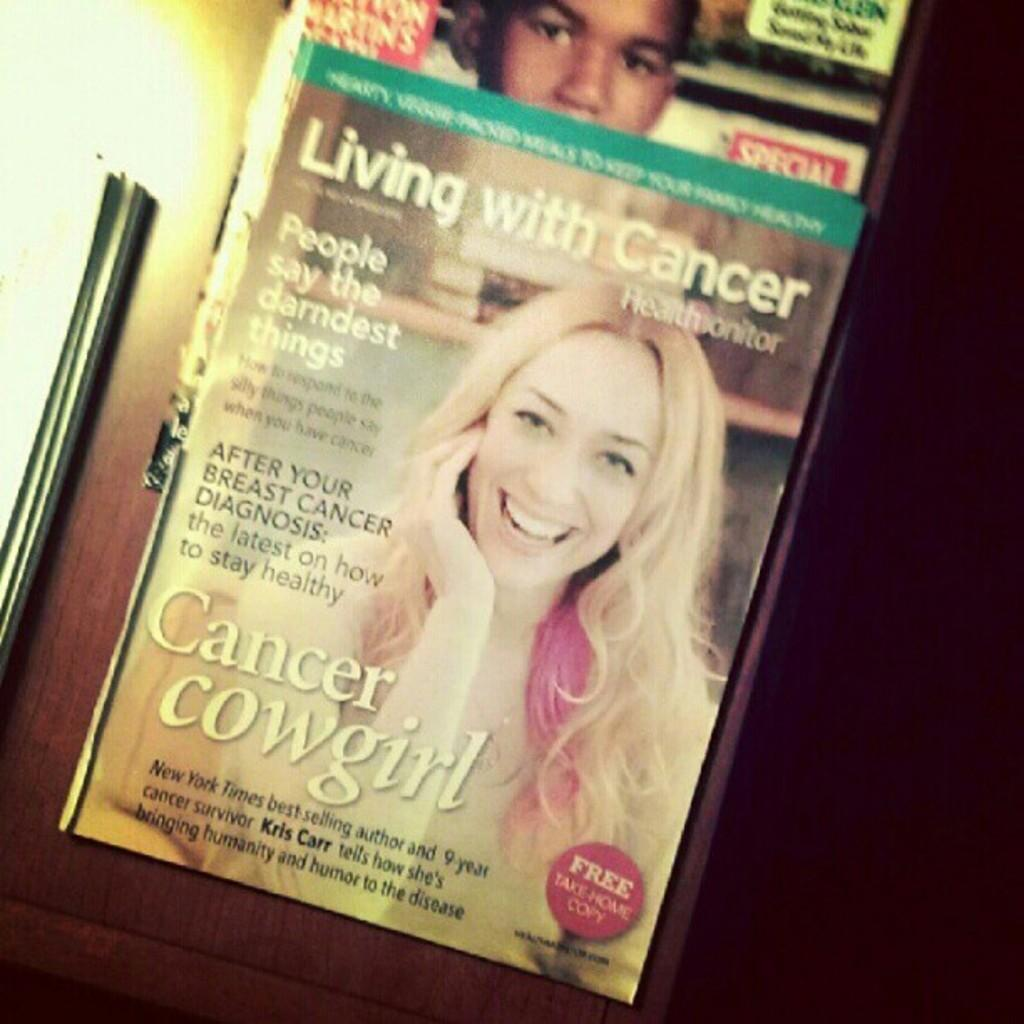What objects are on the table in the image? There are books on the table in the image. How many people are present in the image? There are two persons in the image. Can you describe the books on the table? The books have writing on them. What type of songs is the minister singing in the image? There is no minister or singing present in the image; it features books on a table and two persons. 